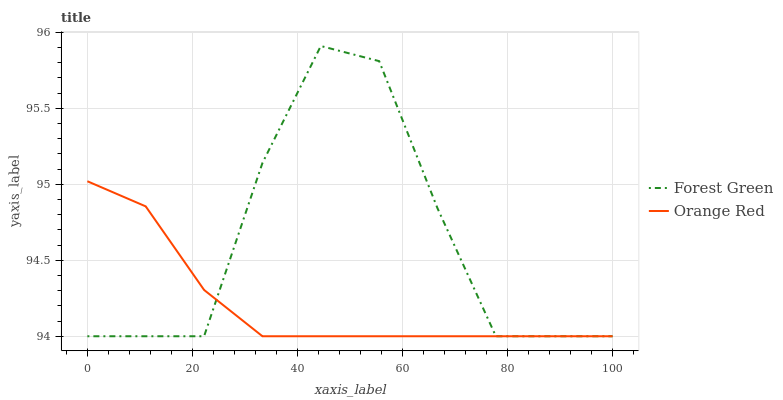Does Orange Red have the maximum area under the curve?
Answer yes or no. No. Is Orange Red the roughest?
Answer yes or no. No. Does Orange Red have the highest value?
Answer yes or no. No. 